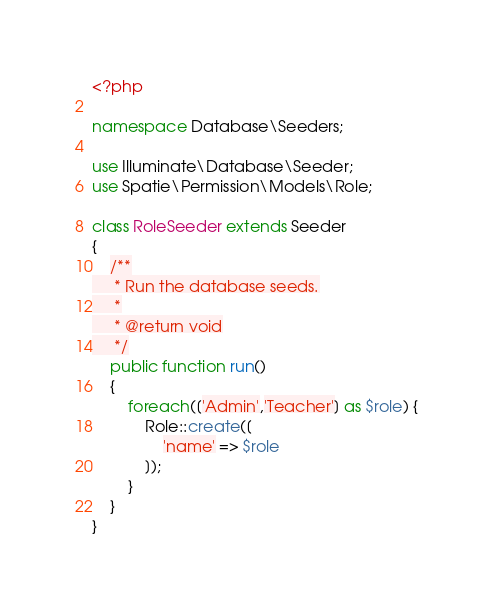Convert code to text. <code><loc_0><loc_0><loc_500><loc_500><_PHP_><?php

namespace Database\Seeders;

use Illuminate\Database\Seeder;
use Spatie\Permission\Models\Role;

class RoleSeeder extends Seeder
{
    /**
     * Run the database seeds.
     *
     * @return void
     */
    public function run()
    {
        foreach(['Admin','Teacher'] as $role) {
            Role::create([
                'name' => $role
            ]);
        }
    }
}
</code> 